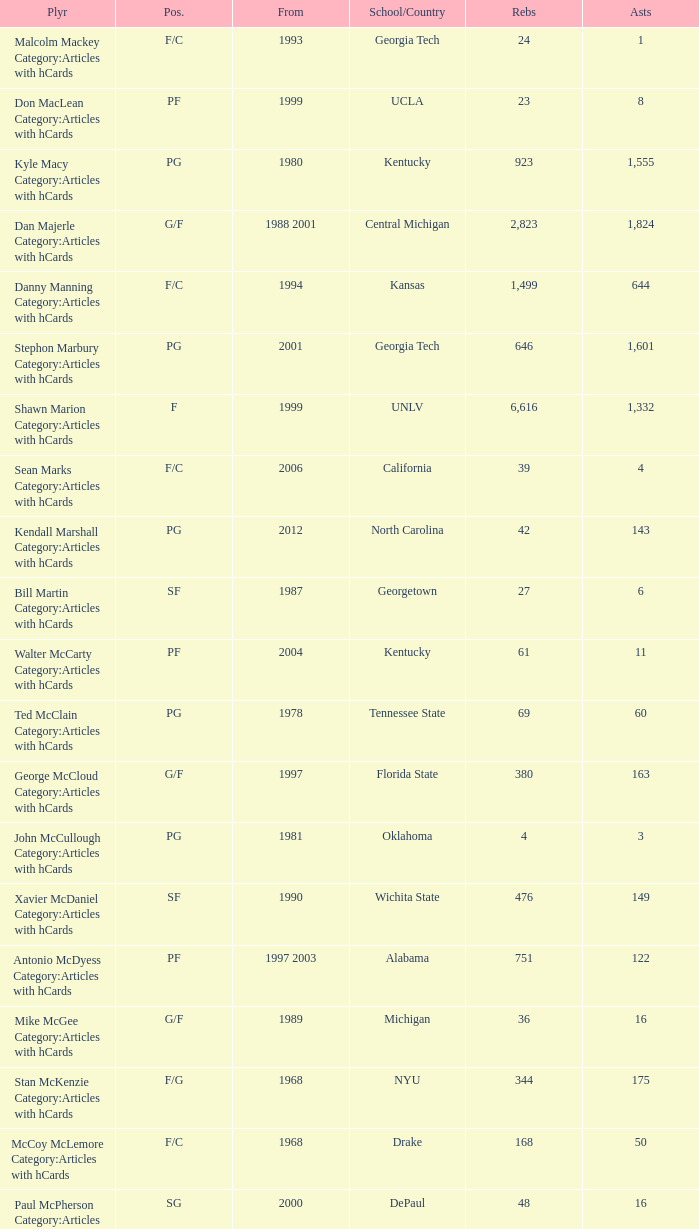Could you parse the entire table as a dict? {'header': ['Plyr', 'Pos.', 'From', 'School/Country', 'Rebs', 'Asts'], 'rows': [['Malcolm Mackey Category:Articles with hCards', 'F/C', '1993', 'Georgia Tech', '24', '1'], ['Don MacLean Category:Articles with hCards', 'PF', '1999', 'UCLA', '23', '8'], ['Kyle Macy Category:Articles with hCards', 'PG', '1980', 'Kentucky', '923', '1,555'], ['Dan Majerle Category:Articles with hCards', 'G/F', '1988 2001', 'Central Michigan', '2,823', '1,824'], ['Danny Manning Category:Articles with hCards', 'F/C', '1994', 'Kansas', '1,499', '644'], ['Stephon Marbury Category:Articles with hCards', 'PG', '2001', 'Georgia Tech', '646', '1,601'], ['Shawn Marion Category:Articles with hCards', 'F', '1999', 'UNLV', '6,616', '1,332'], ['Sean Marks Category:Articles with hCards', 'F/C', '2006', 'California', '39', '4'], ['Kendall Marshall Category:Articles with hCards', 'PG', '2012', 'North Carolina', '42', '143'], ['Bill Martin Category:Articles with hCards', 'SF', '1987', 'Georgetown', '27', '6'], ['Walter McCarty Category:Articles with hCards', 'PF', '2004', 'Kentucky', '61', '11'], ['Ted McClain Category:Articles with hCards', 'PG', '1978', 'Tennessee State', '69', '60'], ['George McCloud Category:Articles with hCards', 'G/F', '1997', 'Florida State', '380', '163'], ['John McCullough Category:Articles with hCards', 'PG', '1981', 'Oklahoma', '4', '3'], ['Xavier McDaniel Category:Articles with hCards', 'SF', '1990', 'Wichita State', '476', '149'], ['Antonio McDyess Category:Articles with hCards', 'PF', '1997 2003', 'Alabama', '751', '122'], ['Mike McGee Category:Articles with hCards', 'G/F', '1989', 'Michigan', '36', '16'], ['Stan McKenzie Category:Articles with hCards', 'F/G', '1968', 'NYU', '344', '175'], ['McCoy McLemore Category:Articles with hCards', 'F/C', '1968', 'Drake', '168', '50'], ['Paul McPherson Category:Articles with hCards', 'SG', '2000', 'DePaul', '48', '16'], ['Gary Melchionni Category:Articles with hCards', 'PG', '1973', 'Duke', '329', '298'], ['Loren Meyer Category:Articles with hCards', 'C', '1996', 'Iowa State', '96', '12'], ['Marko Milič Category:Articles with hCards', 'G/F', '1997', 'Slovenia', '30', '14'], ['Oliver Miller Category:Articles with hCards', 'C', '1992 1999', 'Arkansas', '1,012', '430'], ['Otto Moore Category:Articles with hCards', 'C/F', '1971', 'Texas Pan–Am', '540', '88'], ['Ron Moore Category:Articles with hCards', 'C', '1987', 'West Virginia State', '6', '0'], ['Chris Morris Category:Articles with hCards', 'SF', '1998', 'Auburn', '121', '23'], ['Marcus Morris Category:Articles with hCards', 'F', '2013', 'Kansas', '66', '16'], ['Markieff Morris Category:Articles with hCards', 'PF', '2011', 'Kansas', '681', '174'], ['Mike Morrison Category:Articles with hCards', 'G', '1989', 'Loyola Maryland', '20', '11'], ['Jerrod Mustaf Category:Articles with hCards', 'F/C', '1991', 'Maryland', '283', '63']]} Who has the high assists in 2000? 16.0. 